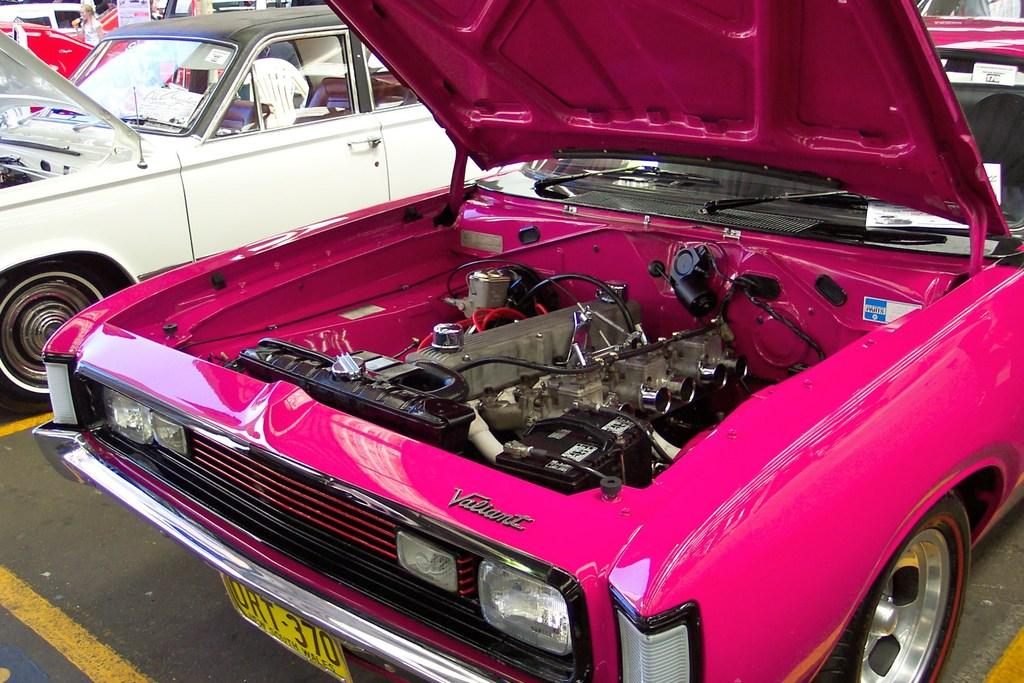What types of objects are present in the image? There are vehicles in the image. Can you describe a specific vehicle in the image? There is a pink color vehicle in the image. What can be seen in the pink vehicle? The pink vehicle has an engine part visible and wires visible. Are there any identifiers on the pink vehicle? Yes, there are name plates attached to the pink vehicle. What flavor of goldfish crackers is being eaten by the brain in the image? There is no brain or goldfish crackers present in the image. 